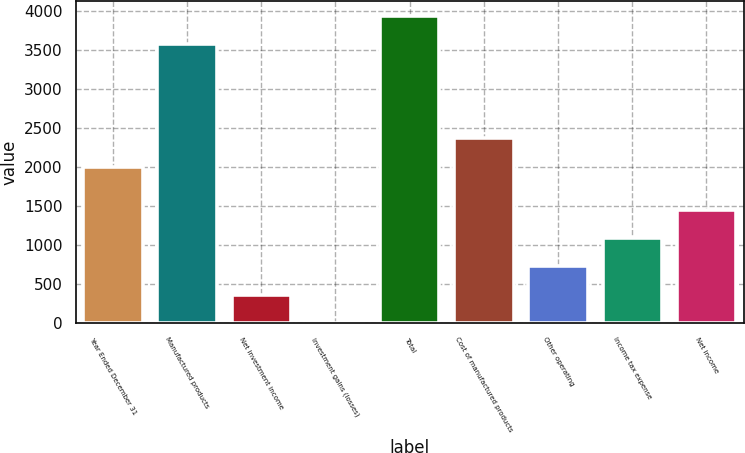Convert chart to OTSL. <chart><loc_0><loc_0><loc_500><loc_500><bar_chart><fcel>Year Ended December 31<fcel>Manufactured products<fcel>Net investment income<fcel>Investment gains (losses)<fcel>Total<fcel>Cost of manufactured products<fcel>Other operating<fcel>Income tax expense<fcel>Net income<nl><fcel>2005<fcel>3568<fcel>365.3<fcel>2<fcel>3931.3<fcel>2368.3<fcel>728.6<fcel>1091.9<fcel>1455.2<nl></chart> 